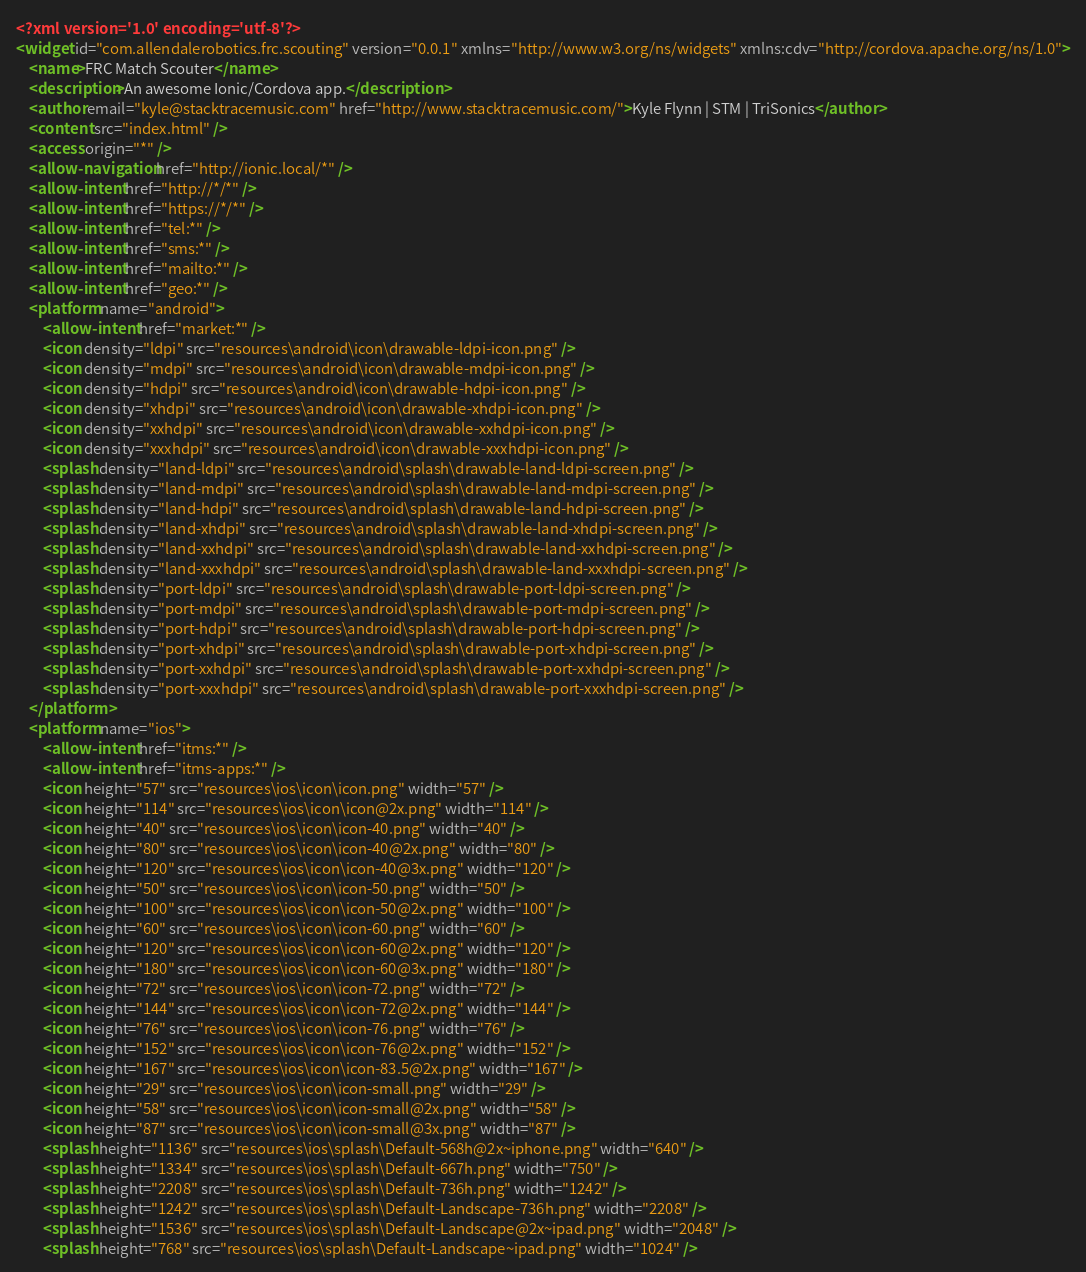<code> <loc_0><loc_0><loc_500><loc_500><_XML_><?xml version='1.0' encoding='utf-8'?>
<widget id="com.allendalerobotics.frc.scouting" version="0.0.1" xmlns="http://www.w3.org/ns/widgets" xmlns:cdv="http://cordova.apache.org/ns/1.0">
    <name>FRC Match Scouter</name>
    <description>An awesome Ionic/Cordova app.</description>
    <author email="kyle@stacktracemusic.com" href="http://www.stacktracemusic.com/">Kyle Flynn | STM | TriSonics</author>
    <content src="index.html" />
    <access origin="*" />
    <allow-navigation href="http://ionic.local/*" />
    <allow-intent href="http://*/*" />
    <allow-intent href="https://*/*" />
    <allow-intent href="tel:*" />
    <allow-intent href="sms:*" />
    <allow-intent href="mailto:*" />
    <allow-intent href="geo:*" />
    <platform name="android">
        <allow-intent href="market:*" />
        <icon density="ldpi" src="resources\android\icon\drawable-ldpi-icon.png" />
        <icon density="mdpi" src="resources\android\icon\drawable-mdpi-icon.png" />
        <icon density="hdpi" src="resources\android\icon\drawable-hdpi-icon.png" />
        <icon density="xhdpi" src="resources\android\icon\drawable-xhdpi-icon.png" />
        <icon density="xxhdpi" src="resources\android\icon\drawable-xxhdpi-icon.png" />
        <icon density="xxxhdpi" src="resources\android\icon\drawable-xxxhdpi-icon.png" />
        <splash density="land-ldpi" src="resources\android\splash\drawable-land-ldpi-screen.png" />
        <splash density="land-mdpi" src="resources\android\splash\drawable-land-mdpi-screen.png" />
        <splash density="land-hdpi" src="resources\android\splash\drawable-land-hdpi-screen.png" />
        <splash density="land-xhdpi" src="resources\android\splash\drawable-land-xhdpi-screen.png" />
        <splash density="land-xxhdpi" src="resources\android\splash\drawable-land-xxhdpi-screen.png" />
        <splash density="land-xxxhdpi" src="resources\android\splash\drawable-land-xxxhdpi-screen.png" />
        <splash density="port-ldpi" src="resources\android\splash\drawable-port-ldpi-screen.png" />
        <splash density="port-mdpi" src="resources\android\splash\drawable-port-mdpi-screen.png" />
        <splash density="port-hdpi" src="resources\android\splash\drawable-port-hdpi-screen.png" />
        <splash density="port-xhdpi" src="resources\android\splash\drawable-port-xhdpi-screen.png" />
        <splash density="port-xxhdpi" src="resources\android\splash\drawable-port-xxhdpi-screen.png" />
        <splash density="port-xxxhdpi" src="resources\android\splash\drawable-port-xxxhdpi-screen.png" />
    </platform>
    <platform name="ios">
        <allow-intent href="itms:*" />
        <allow-intent href="itms-apps:*" />
        <icon height="57" src="resources\ios\icon\icon.png" width="57" />
        <icon height="114" src="resources\ios\icon\icon@2x.png" width="114" />
        <icon height="40" src="resources\ios\icon\icon-40.png" width="40" />
        <icon height="80" src="resources\ios\icon\icon-40@2x.png" width="80" />
        <icon height="120" src="resources\ios\icon\icon-40@3x.png" width="120" />
        <icon height="50" src="resources\ios\icon\icon-50.png" width="50" />
        <icon height="100" src="resources\ios\icon\icon-50@2x.png" width="100" />
        <icon height="60" src="resources\ios\icon\icon-60.png" width="60" />
        <icon height="120" src="resources\ios\icon\icon-60@2x.png" width="120" />
        <icon height="180" src="resources\ios\icon\icon-60@3x.png" width="180" />
        <icon height="72" src="resources\ios\icon\icon-72.png" width="72" />
        <icon height="144" src="resources\ios\icon\icon-72@2x.png" width="144" />
        <icon height="76" src="resources\ios\icon\icon-76.png" width="76" />
        <icon height="152" src="resources\ios\icon\icon-76@2x.png" width="152" />
        <icon height="167" src="resources\ios\icon\icon-83.5@2x.png" width="167" />
        <icon height="29" src="resources\ios\icon\icon-small.png" width="29" />
        <icon height="58" src="resources\ios\icon\icon-small@2x.png" width="58" />
        <icon height="87" src="resources\ios\icon\icon-small@3x.png" width="87" />
        <splash height="1136" src="resources\ios\splash\Default-568h@2x~iphone.png" width="640" />
        <splash height="1334" src="resources\ios\splash\Default-667h.png" width="750" />
        <splash height="2208" src="resources\ios\splash\Default-736h.png" width="1242" />
        <splash height="1242" src="resources\ios\splash\Default-Landscape-736h.png" width="2208" />
        <splash height="1536" src="resources\ios\splash\Default-Landscape@2x~ipad.png" width="2048" />
        <splash height="768" src="resources\ios\splash\Default-Landscape~ipad.png" width="1024" /></code> 